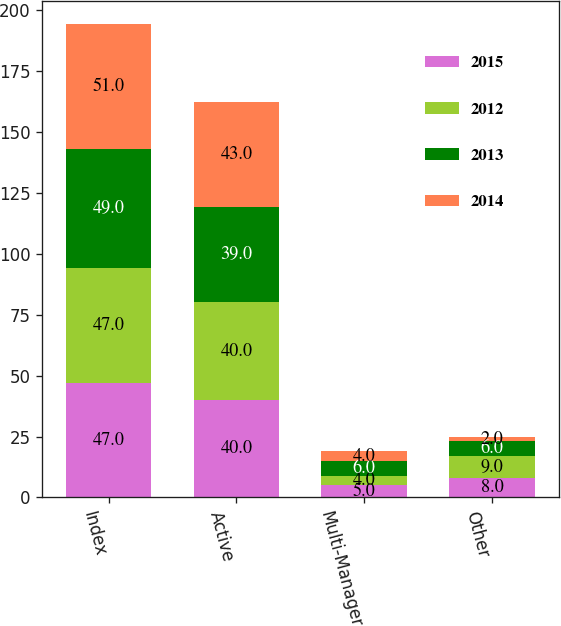Convert chart to OTSL. <chart><loc_0><loc_0><loc_500><loc_500><stacked_bar_chart><ecel><fcel>Index<fcel>Active<fcel>Multi-Manager<fcel>Other<nl><fcel>2015<fcel>47<fcel>40<fcel>5<fcel>8<nl><fcel>2012<fcel>47<fcel>40<fcel>4<fcel>9<nl><fcel>2013<fcel>49<fcel>39<fcel>6<fcel>6<nl><fcel>2014<fcel>51<fcel>43<fcel>4<fcel>2<nl></chart> 